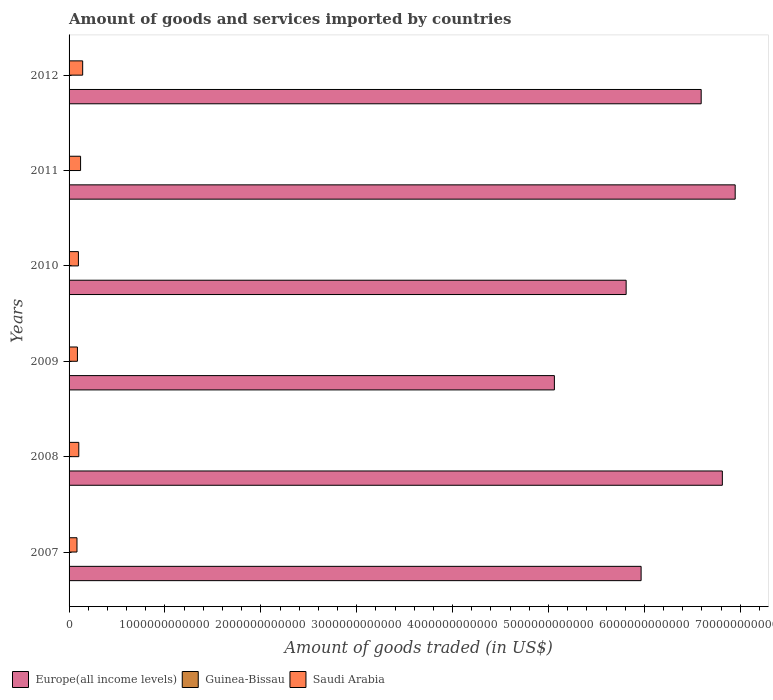How many different coloured bars are there?
Your answer should be compact. 3. Are the number of bars on each tick of the Y-axis equal?
Provide a succinct answer. Yes. What is the label of the 4th group of bars from the top?
Offer a terse response. 2009. In how many cases, is the number of bars for a given year not equal to the number of legend labels?
Offer a terse response. 0. What is the total amount of goods and services imported in Saudi Arabia in 2008?
Provide a short and direct response. 1.01e+11. Across all years, what is the maximum total amount of goods and services imported in Guinea-Bissau?
Ensure brevity in your answer.  2.40e+08. Across all years, what is the minimum total amount of goods and services imported in Saudi Arabia?
Keep it short and to the point. 8.26e+1. In which year was the total amount of goods and services imported in Guinea-Bissau minimum?
Provide a succinct answer. 2007. What is the total total amount of goods and services imported in Guinea-Bissau in the graph?
Provide a succinct answer. 1.19e+09. What is the difference between the total amount of goods and services imported in Europe(all income levels) in 2011 and that in 2012?
Give a very brief answer. 3.55e+11. What is the difference between the total amount of goods and services imported in Saudi Arabia in 2011 and the total amount of goods and services imported in Guinea-Bissau in 2007?
Give a very brief answer. 1.20e+11. What is the average total amount of goods and services imported in Saudi Arabia per year?
Make the answer very short. 1.05e+11. In the year 2010, what is the difference between the total amount of goods and services imported in Guinea-Bissau and total amount of goods and services imported in Europe(all income levels)?
Keep it short and to the point. -5.81e+12. In how many years, is the total amount of goods and services imported in Europe(all income levels) greater than 6600000000000 US$?
Your answer should be compact. 2. What is the ratio of the total amount of goods and services imported in Guinea-Bissau in 2007 to that in 2010?
Provide a short and direct response. 0.85. Is the difference between the total amount of goods and services imported in Guinea-Bissau in 2007 and 2012 greater than the difference between the total amount of goods and services imported in Europe(all income levels) in 2007 and 2012?
Offer a very short reply. Yes. What is the difference between the highest and the second highest total amount of goods and services imported in Europe(all income levels)?
Offer a terse response. 1.34e+11. What is the difference between the highest and the lowest total amount of goods and services imported in Guinea-Bissau?
Offer a terse response. 7.23e+07. What does the 1st bar from the top in 2010 represents?
Provide a succinct answer. Saudi Arabia. What does the 1st bar from the bottom in 2007 represents?
Your response must be concise. Europe(all income levels). Are all the bars in the graph horizontal?
Make the answer very short. Yes. What is the difference between two consecutive major ticks on the X-axis?
Give a very brief answer. 1.00e+12. Are the values on the major ticks of X-axis written in scientific E-notation?
Offer a terse response. No. What is the title of the graph?
Offer a very short reply. Amount of goods and services imported by countries. What is the label or title of the X-axis?
Provide a short and direct response. Amount of goods traded (in US$). What is the Amount of goods traded (in US$) in Europe(all income levels) in 2007?
Provide a succinct answer. 5.97e+12. What is the Amount of goods traded (in US$) in Guinea-Bissau in 2007?
Provide a short and direct response. 1.68e+08. What is the Amount of goods traded (in US$) in Saudi Arabia in 2007?
Provide a short and direct response. 8.26e+1. What is the Amount of goods traded (in US$) of Europe(all income levels) in 2008?
Provide a short and direct response. 6.81e+12. What is the Amount of goods traded (in US$) of Guinea-Bissau in 2008?
Offer a terse response. 1.99e+08. What is the Amount of goods traded (in US$) in Saudi Arabia in 2008?
Make the answer very short. 1.01e+11. What is the Amount of goods traded (in US$) of Europe(all income levels) in 2009?
Give a very brief answer. 5.06e+12. What is the Amount of goods traded (in US$) of Guinea-Bissau in 2009?
Offer a very short reply. 2.02e+08. What is the Amount of goods traded (in US$) of Saudi Arabia in 2009?
Offer a very short reply. 8.71e+1. What is the Amount of goods traded (in US$) of Europe(all income levels) in 2010?
Make the answer very short. 5.81e+12. What is the Amount of goods traded (in US$) in Guinea-Bissau in 2010?
Offer a very short reply. 1.97e+08. What is the Amount of goods traded (in US$) of Saudi Arabia in 2010?
Your answer should be very brief. 9.74e+1. What is the Amount of goods traded (in US$) in Europe(all income levels) in 2011?
Your answer should be compact. 6.95e+12. What is the Amount of goods traded (in US$) in Guinea-Bissau in 2011?
Provide a short and direct response. 2.40e+08. What is the Amount of goods traded (in US$) of Saudi Arabia in 2011?
Offer a very short reply. 1.20e+11. What is the Amount of goods traded (in US$) of Europe(all income levels) in 2012?
Your answer should be compact. 6.59e+12. What is the Amount of goods traded (in US$) in Guinea-Bissau in 2012?
Offer a very short reply. 1.82e+08. What is the Amount of goods traded (in US$) in Saudi Arabia in 2012?
Make the answer very short. 1.42e+11. Across all years, what is the maximum Amount of goods traded (in US$) in Europe(all income levels)?
Give a very brief answer. 6.95e+12. Across all years, what is the maximum Amount of goods traded (in US$) of Guinea-Bissau?
Your response must be concise. 2.40e+08. Across all years, what is the maximum Amount of goods traded (in US$) of Saudi Arabia?
Provide a succinct answer. 1.42e+11. Across all years, what is the minimum Amount of goods traded (in US$) in Europe(all income levels)?
Make the answer very short. 5.06e+12. Across all years, what is the minimum Amount of goods traded (in US$) of Guinea-Bissau?
Keep it short and to the point. 1.68e+08. Across all years, what is the minimum Amount of goods traded (in US$) of Saudi Arabia?
Provide a succinct answer. 8.26e+1. What is the total Amount of goods traded (in US$) in Europe(all income levels) in the graph?
Your answer should be compact. 3.72e+13. What is the total Amount of goods traded (in US$) of Guinea-Bissau in the graph?
Give a very brief answer. 1.19e+09. What is the total Amount of goods traded (in US$) of Saudi Arabia in the graph?
Offer a terse response. 6.30e+11. What is the difference between the Amount of goods traded (in US$) of Europe(all income levels) in 2007 and that in 2008?
Ensure brevity in your answer.  -8.47e+11. What is the difference between the Amount of goods traded (in US$) in Guinea-Bissau in 2007 and that in 2008?
Offer a terse response. -3.09e+07. What is the difference between the Amount of goods traded (in US$) in Saudi Arabia in 2007 and that in 2008?
Make the answer very short. -1.89e+1. What is the difference between the Amount of goods traded (in US$) in Europe(all income levels) in 2007 and that in 2009?
Offer a very short reply. 9.04e+11. What is the difference between the Amount of goods traded (in US$) in Guinea-Bissau in 2007 and that in 2009?
Ensure brevity in your answer.  -3.44e+07. What is the difference between the Amount of goods traded (in US$) in Saudi Arabia in 2007 and that in 2009?
Offer a terse response. -4.48e+09. What is the difference between the Amount of goods traded (in US$) of Europe(all income levels) in 2007 and that in 2010?
Keep it short and to the point. 1.56e+11. What is the difference between the Amount of goods traded (in US$) in Guinea-Bissau in 2007 and that in 2010?
Offer a very short reply. -2.87e+07. What is the difference between the Amount of goods traded (in US$) in Saudi Arabia in 2007 and that in 2010?
Ensure brevity in your answer.  -1.48e+1. What is the difference between the Amount of goods traded (in US$) of Europe(all income levels) in 2007 and that in 2011?
Give a very brief answer. -9.81e+11. What is the difference between the Amount of goods traded (in US$) of Guinea-Bissau in 2007 and that in 2011?
Provide a short and direct response. -7.23e+07. What is the difference between the Amount of goods traded (in US$) of Saudi Arabia in 2007 and that in 2011?
Offer a very short reply. -3.74e+1. What is the difference between the Amount of goods traded (in US$) in Europe(all income levels) in 2007 and that in 2012?
Provide a short and direct response. -6.26e+11. What is the difference between the Amount of goods traded (in US$) of Guinea-Bissau in 2007 and that in 2012?
Make the answer very short. -1.39e+07. What is the difference between the Amount of goods traded (in US$) of Saudi Arabia in 2007 and that in 2012?
Ensure brevity in your answer.  -5.92e+1. What is the difference between the Amount of goods traded (in US$) of Europe(all income levels) in 2008 and that in 2009?
Offer a very short reply. 1.75e+12. What is the difference between the Amount of goods traded (in US$) in Guinea-Bissau in 2008 and that in 2009?
Ensure brevity in your answer.  -3.53e+06. What is the difference between the Amount of goods traded (in US$) in Saudi Arabia in 2008 and that in 2009?
Offer a very short reply. 1.44e+1. What is the difference between the Amount of goods traded (in US$) in Europe(all income levels) in 2008 and that in 2010?
Provide a short and direct response. 1.00e+12. What is the difference between the Amount of goods traded (in US$) in Guinea-Bissau in 2008 and that in 2010?
Give a very brief answer. 2.22e+06. What is the difference between the Amount of goods traded (in US$) in Saudi Arabia in 2008 and that in 2010?
Give a very brief answer. 4.02e+09. What is the difference between the Amount of goods traded (in US$) in Europe(all income levels) in 2008 and that in 2011?
Keep it short and to the point. -1.34e+11. What is the difference between the Amount of goods traded (in US$) in Guinea-Bissau in 2008 and that in 2011?
Keep it short and to the point. -4.14e+07. What is the difference between the Amount of goods traded (in US$) of Saudi Arabia in 2008 and that in 2011?
Your response must be concise. -1.85e+1. What is the difference between the Amount of goods traded (in US$) in Europe(all income levels) in 2008 and that in 2012?
Your response must be concise. 2.21e+11. What is the difference between the Amount of goods traded (in US$) of Guinea-Bissau in 2008 and that in 2012?
Your response must be concise. 1.70e+07. What is the difference between the Amount of goods traded (in US$) of Saudi Arabia in 2008 and that in 2012?
Make the answer very short. -4.03e+1. What is the difference between the Amount of goods traded (in US$) of Europe(all income levels) in 2009 and that in 2010?
Keep it short and to the point. -7.48e+11. What is the difference between the Amount of goods traded (in US$) in Guinea-Bissau in 2009 and that in 2010?
Your answer should be very brief. 5.75e+06. What is the difference between the Amount of goods traded (in US$) of Saudi Arabia in 2009 and that in 2010?
Offer a very short reply. -1.04e+1. What is the difference between the Amount of goods traded (in US$) in Europe(all income levels) in 2009 and that in 2011?
Offer a terse response. -1.89e+12. What is the difference between the Amount of goods traded (in US$) of Guinea-Bissau in 2009 and that in 2011?
Your answer should be very brief. -3.79e+07. What is the difference between the Amount of goods traded (in US$) in Saudi Arabia in 2009 and that in 2011?
Keep it short and to the point. -3.29e+1. What is the difference between the Amount of goods traded (in US$) in Europe(all income levels) in 2009 and that in 2012?
Keep it short and to the point. -1.53e+12. What is the difference between the Amount of goods traded (in US$) of Guinea-Bissau in 2009 and that in 2012?
Your response must be concise. 2.06e+07. What is the difference between the Amount of goods traded (in US$) in Saudi Arabia in 2009 and that in 2012?
Your answer should be compact. -5.47e+1. What is the difference between the Amount of goods traded (in US$) in Europe(all income levels) in 2010 and that in 2011?
Ensure brevity in your answer.  -1.14e+12. What is the difference between the Amount of goods traded (in US$) of Guinea-Bissau in 2010 and that in 2011?
Give a very brief answer. -4.36e+07. What is the difference between the Amount of goods traded (in US$) in Saudi Arabia in 2010 and that in 2011?
Provide a succinct answer. -2.25e+1. What is the difference between the Amount of goods traded (in US$) in Europe(all income levels) in 2010 and that in 2012?
Offer a terse response. -7.83e+11. What is the difference between the Amount of goods traded (in US$) in Guinea-Bissau in 2010 and that in 2012?
Your answer should be very brief. 1.48e+07. What is the difference between the Amount of goods traded (in US$) of Saudi Arabia in 2010 and that in 2012?
Your answer should be very brief. -4.44e+1. What is the difference between the Amount of goods traded (in US$) in Europe(all income levels) in 2011 and that in 2012?
Provide a short and direct response. 3.55e+11. What is the difference between the Amount of goods traded (in US$) in Guinea-Bissau in 2011 and that in 2012?
Offer a very short reply. 5.84e+07. What is the difference between the Amount of goods traded (in US$) of Saudi Arabia in 2011 and that in 2012?
Offer a very short reply. -2.18e+1. What is the difference between the Amount of goods traded (in US$) of Europe(all income levels) in 2007 and the Amount of goods traded (in US$) of Guinea-Bissau in 2008?
Provide a succinct answer. 5.97e+12. What is the difference between the Amount of goods traded (in US$) in Europe(all income levels) in 2007 and the Amount of goods traded (in US$) in Saudi Arabia in 2008?
Provide a short and direct response. 5.86e+12. What is the difference between the Amount of goods traded (in US$) of Guinea-Bissau in 2007 and the Amount of goods traded (in US$) of Saudi Arabia in 2008?
Provide a short and direct response. -1.01e+11. What is the difference between the Amount of goods traded (in US$) of Europe(all income levels) in 2007 and the Amount of goods traded (in US$) of Guinea-Bissau in 2009?
Your response must be concise. 5.97e+12. What is the difference between the Amount of goods traded (in US$) of Europe(all income levels) in 2007 and the Amount of goods traded (in US$) of Saudi Arabia in 2009?
Offer a terse response. 5.88e+12. What is the difference between the Amount of goods traded (in US$) of Guinea-Bissau in 2007 and the Amount of goods traded (in US$) of Saudi Arabia in 2009?
Make the answer very short. -8.69e+1. What is the difference between the Amount of goods traded (in US$) in Europe(all income levels) in 2007 and the Amount of goods traded (in US$) in Guinea-Bissau in 2010?
Your answer should be very brief. 5.97e+12. What is the difference between the Amount of goods traded (in US$) of Europe(all income levels) in 2007 and the Amount of goods traded (in US$) of Saudi Arabia in 2010?
Offer a terse response. 5.87e+12. What is the difference between the Amount of goods traded (in US$) in Guinea-Bissau in 2007 and the Amount of goods traded (in US$) in Saudi Arabia in 2010?
Keep it short and to the point. -9.73e+1. What is the difference between the Amount of goods traded (in US$) in Europe(all income levels) in 2007 and the Amount of goods traded (in US$) in Guinea-Bissau in 2011?
Your answer should be very brief. 5.97e+12. What is the difference between the Amount of goods traded (in US$) in Europe(all income levels) in 2007 and the Amount of goods traded (in US$) in Saudi Arabia in 2011?
Offer a very short reply. 5.85e+12. What is the difference between the Amount of goods traded (in US$) in Guinea-Bissau in 2007 and the Amount of goods traded (in US$) in Saudi Arabia in 2011?
Provide a short and direct response. -1.20e+11. What is the difference between the Amount of goods traded (in US$) of Europe(all income levels) in 2007 and the Amount of goods traded (in US$) of Guinea-Bissau in 2012?
Provide a succinct answer. 5.97e+12. What is the difference between the Amount of goods traded (in US$) of Europe(all income levels) in 2007 and the Amount of goods traded (in US$) of Saudi Arabia in 2012?
Provide a succinct answer. 5.82e+12. What is the difference between the Amount of goods traded (in US$) in Guinea-Bissau in 2007 and the Amount of goods traded (in US$) in Saudi Arabia in 2012?
Offer a terse response. -1.42e+11. What is the difference between the Amount of goods traded (in US$) in Europe(all income levels) in 2008 and the Amount of goods traded (in US$) in Guinea-Bissau in 2009?
Provide a succinct answer. 6.81e+12. What is the difference between the Amount of goods traded (in US$) of Europe(all income levels) in 2008 and the Amount of goods traded (in US$) of Saudi Arabia in 2009?
Make the answer very short. 6.73e+12. What is the difference between the Amount of goods traded (in US$) of Guinea-Bissau in 2008 and the Amount of goods traded (in US$) of Saudi Arabia in 2009?
Your answer should be very brief. -8.69e+1. What is the difference between the Amount of goods traded (in US$) of Europe(all income levels) in 2008 and the Amount of goods traded (in US$) of Guinea-Bissau in 2010?
Keep it short and to the point. 6.81e+12. What is the difference between the Amount of goods traded (in US$) in Europe(all income levels) in 2008 and the Amount of goods traded (in US$) in Saudi Arabia in 2010?
Make the answer very short. 6.72e+12. What is the difference between the Amount of goods traded (in US$) of Guinea-Bissau in 2008 and the Amount of goods traded (in US$) of Saudi Arabia in 2010?
Ensure brevity in your answer.  -9.72e+1. What is the difference between the Amount of goods traded (in US$) of Europe(all income levels) in 2008 and the Amount of goods traded (in US$) of Guinea-Bissau in 2011?
Your response must be concise. 6.81e+12. What is the difference between the Amount of goods traded (in US$) in Europe(all income levels) in 2008 and the Amount of goods traded (in US$) in Saudi Arabia in 2011?
Your response must be concise. 6.69e+12. What is the difference between the Amount of goods traded (in US$) in Guinea-Bissau in 2008 and the Amount of goods traded (in US$) in Saudi Arabia in 2011?
Make the answer very short. -1.20e+11. What is the difference between the Amount of goods traded (in US$) in Europe(all income levels) in 2008 and the Amount of goods traded (in US$) in Guinea-Bissau in 2012?
Give a very brief answer. 6.81e+12. What is the difference between the Amount of goods traded (in US$) in Europe(all income levels) in 2008 and the Amount of goods traded (in US$) in Saudi Arabia in 2012?
Ensure brevity in your answer.  6.67e+12. What is the difference between the Amount of goods traded (in US$) of Guinea-Bissau in 2008 and the Amount of goods traded (in US$) of Saudi Arabia in 2012?
Your answer should be very brief. -1.42e+11. What is the difference between the Amount of goods traded (in US$) in Europe(all income levels) in 2009 and the Amount of goods traded (in US$) in Guinea-Bissau in 2010?
Offer a very short reply. 5.06e+12. What is the difference between the Amount of goods traded (in US$) in Europe(all income levels) in 2009 and the Amount of goods traded (in US$) in Saudi Arabia in 2010?
Provide a succinct answer. 4.96e+12. What is the difference between the Amount of goods traded (in US$) in Guinea-Bissau in 2009 and the Amount of goods traded (in US$) in Saudi Arabia in 2010?
Offer a very short reply. -9.72e+1. What is the difference between the Amount of goods traded (in US$) of Europe(all income levels) in 2009 and the Amount of goods traded (in US$) of Guinea-Bissau in 2011?
Keep it short and to the point. 5.06e+12. What is the difference between the Amount of goods traded (in US$) of Europe(all income levels) in 2009 and the Amount of goods traded (in US$) of Saudi Arabia in 2011?
Offer a very short reply. 4.94e+12. What is the difference between the Amount of goods traded (in US$) of Guinea-Bissau in 2009 and the Amount of goods traded (in US$) of Saudi Arabia in 2011?
Keep it short and to the point. -1.20e+11. What is the difference between the Amount of goods traded (in US$) in Europe(all income levels) in 2009 and the Amount of goods traded (in US$) in Guinea-Bissau in 2012?
Provide a succinct answer. 5.06e+12. What is the difference between the Amount of goods traded (in US$) in Europe(all income levels) in 2009 and the Amount of goods traded (in US$) in Saudi Arabia in 2012?
Provide a short and direct response. 4.92e+12. What is the difference between the Amount of goods traded (in US$) in Guinea-Bissau in 2009 and the Amount of goods traded (in US$) in Saudi Arabia in 2012?
Your answer should be compact. -1.42e+11. What is the difference between the Amount of goods traded (in US$) in Europe(all income levels) in 2010 and the Amount of goods traded (in US$) in Guinea-Bissau in 2011?
Your response must be concise. 5.81e+12. What is the difference between the Amount of goods traded (in US$) of Europe(all income levels) in 2010 and the Amount of goods traded (in US$) of Saudi Arabia in 2011?
Offer a terse response. 5.69e+12. What is the difference between the Amount of goods traded (in US$) in Guinea-Bissau in 2010 and the Amount of goods traded (in US$) in Saudi Arabia in 2011?
Offer a very short reply. -1.20e+11. What is the difference between the Amount of goods traded (in US$) in Europe(all income levels) in 2010 and the Amount of goods traded (in US$) in Guinea-Bissau in 2012?
Provide a succinct answer. 5.81e+12. What is the difference between the Amount of goods traded (in US$) in Europe(all income levels) in 2010 and the Amount of goods traded (in US$) in Saudi Arabia in 2012?
Keep it short and to the point. 5.67e+12. What is the difference between the Amount of goods traded (in US$) of Guinea-Bissau in 2010 and the Amount of goods traded (in US$) of Saudi Arabia in 2012?
Offer a terse response. -1.42e+11. What is the difference between the Amount of goods traded (in US$) of Europe(all income levels) in 2011 and the Amount of goods traded (in US$) of Guinea-Bissau in 2012?
Offer a very short reply. 6.95e+12. What is the difference between the Amount of goods traded (in US$) of Europe(all income levels) in 2011 and the Amount of goods traded (in US$) of Saudi Arabia in 2012?
Your answer should be compact. 6.80e+12. What is the difference between the Amount of goods traded (in US$) of Guinea-Bissau in 2011 and the Amount of goods traded (in US$) of Saudi Arabia in 2012?
Make the answer very short. -1.42e+11. What is the average Amount of goods traded (in US$) of Europe(all income levels) per year?
Your answer should be very brief. 6.20e+12. What is the average Amount of goods traded (in US$) in Guinea-Bissau per year?
Keep it short and to the point. 1.98e+08. What is the average Amount of goods traded (in US$) of Saudi Arabia per year?
Provide a short and direct response. 1.05e+11. In the year 2007, what is the difference between the Amount of goods traded (in US$) in Europe(all income levels) and Amount of goods traded (in US$) in Guinea-Bissau?
Keep it short and to the point. 5.97e+12. In the year 2007, what is the difference between the Amount of goods traded (in US$) of Europe(all income levels) and Amount of goods traded (in US$) of Saudi Arabia?
Offer a terse response. 5.88e+12. In the year 2007, what is the difference between the Amount of goods traded (in US$) in Guinea-Bissau and Amount of goods traded (in US$) in Saudi Arabia?
Ensure brevity in your answer.  -8.24e+1. In the year 2008, what is the difference between the Amount of goods traded (in US$) in Europe(all income levels) and Amount of goods traded (in US$) in Guinea-Bissau?
Your answer should be compact. 6.81e+12. In the year 2008, what is the difference between the Amount of goods traded (in US$) in Europe(all income levels) and Amount of goods traded (in US$) in Saudi Arabia?
Your answer should be very brief. 6.71e+12. In the year 2008, what is the difference between the Amount of goods traded (in US$) of Guinea-Bissau and Amount of goods traded (in US$) of Saudi Arabia?
Offer a very short reply. -1.01e+11. In the year 2009, what is the difference between the Amount of goods traded (in US$) of Europe(all income levels) and Amount of goods traded (in US$) of Guinea-Bissau?
Make the answer very short. 5.06e+12. In the year 2009, what is the difference between the Amount of goods traded (in US$) in Europe(all income levels) and Amount of goods traded (in US$) in Saudi Arabia?
Offer a terse response. 4.97e+12. In the year 2009, what is the difference between the Amount of goods traded (in US$) of Guinea-Bissau and Amount of goods traded (in US$) of Saudi Arabia?
Offer a terse response. -8.69e+1. In the year 2010, what is the difference between the Amount of goods traded (in US$) in Europe(all income levels) and Amount of goods traded (in US$) in Guinea-Bissau?
Offer a terse response. 5.81e+12. In the year 2010, what is the difference between the Amount of goods traded (in US$) of Europe(all income levels) and Amount of goods traded (in US$) of Saudi Arabia?
Ensure brevity in your answer.  5.71e+12. In the year 2010, what is the difference between the Amount of goods traded (in US$) in Guinea-Bissau and Amount of goods traded (in US$) in Saudi Arabia?
Provide a succinct answer. -9.72e+1. In the year 2011, what is the difference between the Amount of goods traded (in US$) of Europe(all income levels) and Amount of goods traded (in US$) of Guinea-Bissau?
Your response must be concise. 6.95e+12. In the year 2011, what is the difference between the Amount of goods traded (in US$) of Europe(all income levels) and Amount of goods traded (in US$) of Saudi Arabia?
Offer a terse response. 6.83e+12. In the year 2011, what is the difference between the Amount of goods traded (in US$) of Guinea-Bissau and Amount of goods traded (in US$) of Saudi Arabia?
Make the answer very short. -1.20e+11. In the year 2012, what is the difference between the Amount of goods traded (in US$) in Europe(all income levels) and Amount of goods traded (in US$) in Guinea-Bissau?
Provide a succinct answer. 6.59e+12. In the year 2012, what is the difference between the Amount of goods traded (in US$) in Europe(all income levels) and Amount of goods traded (in US$) in Saudi Arabia?
Provide a short and direct response. 6.45e+12. In the year 2012, what is the difference between the Amount of goods traded (in US$) of Guinea-Bissau and Amount of goods traded (in US$) of Saudi Arabia?
Your answer should be very brief. -1.42e+11. What is the ratio of the Amount of goods traded (in US$) of Europe(all income levels) in 2007 to that in 2008?
Give a very brief answer. 0.88. What is the ratio of the Amount of goods traded (in US$) in Guinea-Bissau in 2007 to that in 2008?
Offer a terse response. 0.84. What is the ratio of the Amount of goods traded (in US$) of Saudi Arabia in 2007 to that in 2008?
Give a very brief answer. 0.81. What is the ratio of the Amount of goods traded (in US$) of Europe(all income levels) in 2007 to that in 2009?
Keep it short and to the point. 1.18. What is the ratio of the Amount of goods traded (in US$) of Guinea-Bissau in 2007 to that in 2009?
Your answer should be very brief. 0.83. What is the ratio of the Amount of goods traded (in US$) in Saudi Arabia in 2007 to that in 2009?
Provide a succinct answer. 0.95. What is the ratio of the Amount of goods traded (in US$) of Europe(all income levels) in 2007 to that in 2010?
Your answer should be very brief. 1.03. What is the ratio of the Amount of goods traded (in US$) of Guinea-Bissau in 2007 to that in 2010?
Provide a short and direct response. 0.85. What is the ratio of the Amount of goods traded (in US$) in Saudi Arabia in 2007 to that in 2010?
Offer a very short reply. 0.85. What is the ratio of the Amount of goods traded (in US$) of Europe(all income levels) in 2007 to that in 2011?
Your answer should be very brief. 0.86. What is the ratio of the Amount of goods traded (in US$) of Guinea-Bissau in 2007 to that in 2011?
Make the answer very short. 0.7. What is the ratio of the Amount of goods traded (in US$) in Saudi Arabia in 2007 to that in 2011?
Keep it short and to the point. 0.69. What is the ratio of the Amount of goods traded (in US$) of Europe(all income levels) in 2007 to that in 2012?
Offer a terse response. 0.91. What is the ratio of the Amount of goods traded (in US$) of Guinea-Bissau in 2007 to that in 2012?
Ensure brevity in your answer.  0.92. What is the ratio of the Amount of goods traded (in US$) of Saudi Arabia in 2007 to that in 2012?
Provide a succinct answer. 0.58. What is the ratio of the Amount of goods traded (in US$) of Europe(all income levels) in 2008 to that in 2009?
Your answer should be compact. 1.35. What is the ratio of the Amount of goods traded (in US$) of Guinea-Bissau in 2008 to that in 2009?
Your answer should be very brief. 0.98. What is the ratio of the Amount of goods traded (in US$) in Saudi Arabia in 2008 to that in 2009?
Ensure brevity in your answer.  1.17. What is the ratio of the Amount of goods traded (in US$) of Europe(all income levels) in 2008 to that in 2010?
Keep it short and to the point. 1.17. What is the ratio of the Amount of goods traded (in US$) of Guinea-Bissau in 2008 to that in 2010?
Your response must be concise. 1.01. What is the ratio of the Amount of goods traded (in US$) in Saudi Arabia in 2008 to that in 2010?
Keep it short and to the point. 1.04. What is the ratio of the Amount of goods traded (in US$) of Europe(all income levels) in 2008 to that in 2011?
Ensure brevity in your answer.  0.98. What is the ratio of the Amount of goods traded (in US$) in Guinea-Bissau in 2008 to that in 2011?
Offer a terse response. 0.83. What is the ratio of the Amount of goods traded (in US$) in Saudi Arabia in 2008 to that in 2011?
Offer a very short reply. 0.85. What is the ratio of the Amount of goods traded (in US$) in Europe(all income levels) in 2008 to that in 2012?
Provide a short and direct response. 1.03. What is the ratio of the Amount of goods traded (in US$) of Guinea-Bissau in 2008 to that in 2012?
Your response must be concise. 1.09. What is the ratio of the Amount of goods traded (in US$) of Saudi Arabia in 2008 to that in 2012?
Your response must be concise. 0.72. What is the ratio of the Amount of goods traded (in US$) of Europe(all income levels) in 2009 to that in 2010?
Your response must be concise. 0.87. What is the ratio of the Amount of goods traded (in US$) in Guinea-Bissau in 2009 to that in 2010?
Give a very brief answer. 1.03. What is the ratio of the Amount of goods traded (in US$) in Saudi Arabia in 2009 to that in 2010?
Make the answer very short. 0.89. What is the ratio of the Amount of goods traded (in US$) in Europe(all income levels) in 2009 to that in 2011?
Provide a succinct answer. 0.73. What is the ratio of the Amount of goods traded (in US$) in Guinea-Bissau in 2009 to that in 2011?
Your answer should be compact. 0.84. What is the ratio of the Amount of goods traded (in US$) in Saudi Arabia in 2009 to that in 2011?
Keep it short and to the point. 0.73. What is the ratio of the Amount of goods traded (in US$) of Europe(all income levels) in 2009 to that in 2012?
Ensure brevity in your answer.  0.77. What is the ratio of the Amount of goods traded (in US$) of Guinea-Bissau in 2009 to that in 2012?
Your answer should be compact. 1.11. What is the ratio of the Amount of goods traded (in US$) of Saudi Arabia in 2009 to that in 2012?
Ensure brevity in your answer.  0.61. What is the ratio of the Amount of goods traded (in US$) in Europe(all income levels) in 2010 to that in 2011?
Give a very brief answer. 0.84. What is the ratio of the Amount of goods traded (in US$) in Guinea-Bissau in 2010 to that in 2011?
Your answer should be compact. 0.82. What is the ratio of the Amount of goods traded (in US$) of Saudi Arabia in 2010 to that in 2011?
Give a very brief answer. 0.81. What is the ratio of the Amount of goods traded (in US$) in Europe(all income levels) in 2010 to that in 2012?
Your answer should be compact. 0.88. What is the ratio of the Amount of goods traded (in US$) of Guinea-Bissau in 2010 to that in 2012?
Give a very brief answer. 1.08. What is the ratio of the Amount of goods traded (in US$) of Saudi Arabia in 2010 to that in 2012?
Make the answer very short. 0.69. What is the ratio of the Amount of goods traded (in US$) of Europe(all income levels) in 2011 to that in 2012?
Provide a succinct answer. 1.05. What is the ratio of the Amount of goods traded (in US$) of Guinea-Bissau in 2011 to that in 2012?
Your answer should be very brief. 1.32. What is the ratio of the Amount of goods traded (in US$) of Saudi Arabia in 2011 to that in 2012?
Offer a very short reply. 0.85. What is the difference between the highest and the second highest Amount of goods traded (in US$) in Europe(all income levels)?
Give a very brief answer. 1.34e+11. What is the difference between the highest and the second highest Amount of goods traded (in US$) of Guinea-Bissau?
Provide a succinct answer. 3.79e+07. What is the difference between the highest and the second highest Amount of goods traded (in US$) in Saudi Arabia?
Provide a short and direct response. 2.18e+1. What is the difference between the highest and the lowest Amount of goods traded (in US$) in Europe(all income levels)?
Ensure brevity in your answer.  1.89e+12. What is the difference between the highest and the lowest Amount of goods traded (in US$) of Guinea-Bissau?
Keep it short and to the point. 7.23e+07. What is the difference between the highest and the lowest Amount of goods traded (in US$) of Saudi Arabia?
Your answer should be very brief. 5.92e+1. 